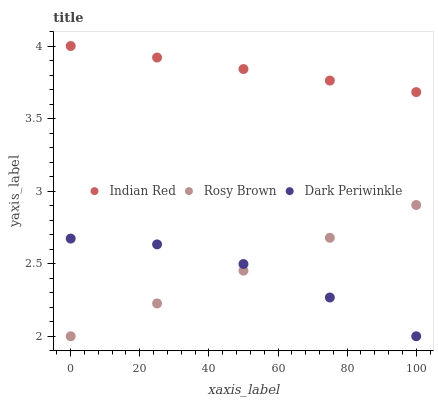Does Dark Periwinkle have the minimum area under the curve?
Answer yes or no. Yes. Does Indian Red have the maximum area under the curve?
Answer yes or no. Yes. Does Indian Red have the minimum area under the curve?
Answer yes or no. No. Does Dark Periwinkle have the maximum area under the curve?
Answer yes or no. No. Is Indian Red the smoothest?
Answer yes or no. Yes. Is Dark Periwinkle the roughest?
Answer yes or no. Yes. Is Dark Periwinkle the smoothest?
Answer yes or no. No. Is Indian Red the roughest?
Answer yes or no. No. Does Rosy Brown have the lowest value?
Answer yes or no. Yes. Does Indian Red have the lowest value?
Answer yes or no. No. Does Indian Red have the highest value?
Answer yes or no. Yes. Does Dark Periwinkle have the highest value?
Answer yes or no. No. Is Rosy Brown less than Indian Red?
Answer yes or no. Yes. Is Indian Red greater than Dark Periwinkle?
Answer yes or no. Yes. Does Dark Periwinkle intersect Rosy Brown?
Answer yes or no. Yes. Is Dark Periwinkle less than Rosy Brown?
Answer yes or no. No. Is Dark Periwinkle greater than Rosy Brown?
Answer yes or no. No. Does Rosy Brown intersect Indian Red?
Answer yes or no. No. 